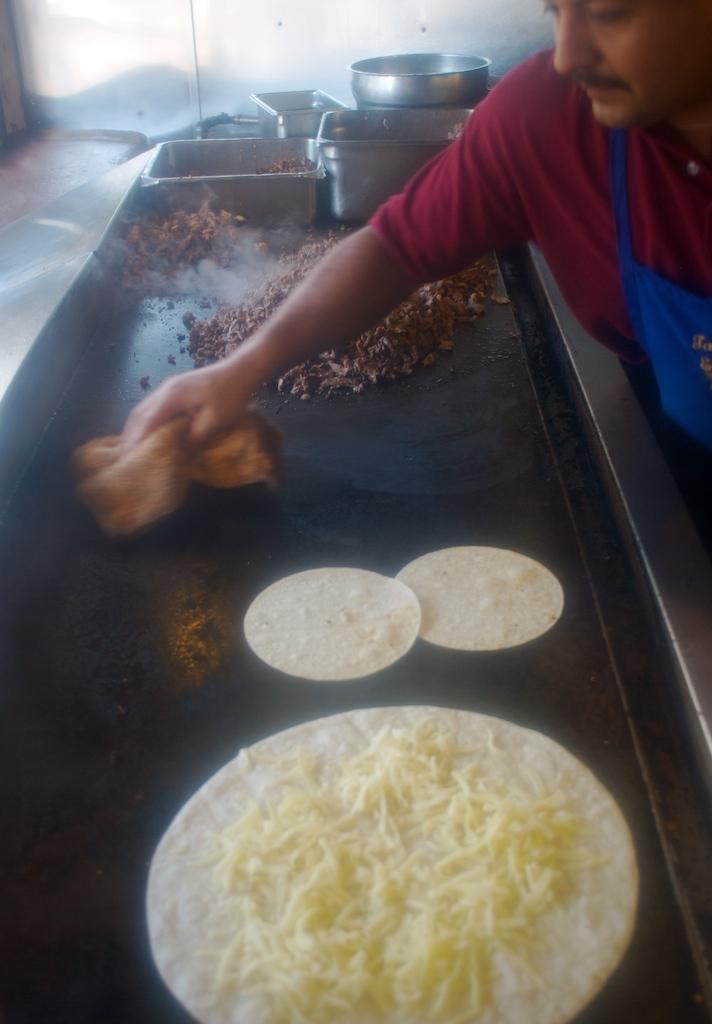In one or two sentences, can you explain what this image depicts? In this picture we can see a person holding a cloth in his hand. There is some food on a black surface. We can see a few kitchen vessels and a steel surface in the background. 